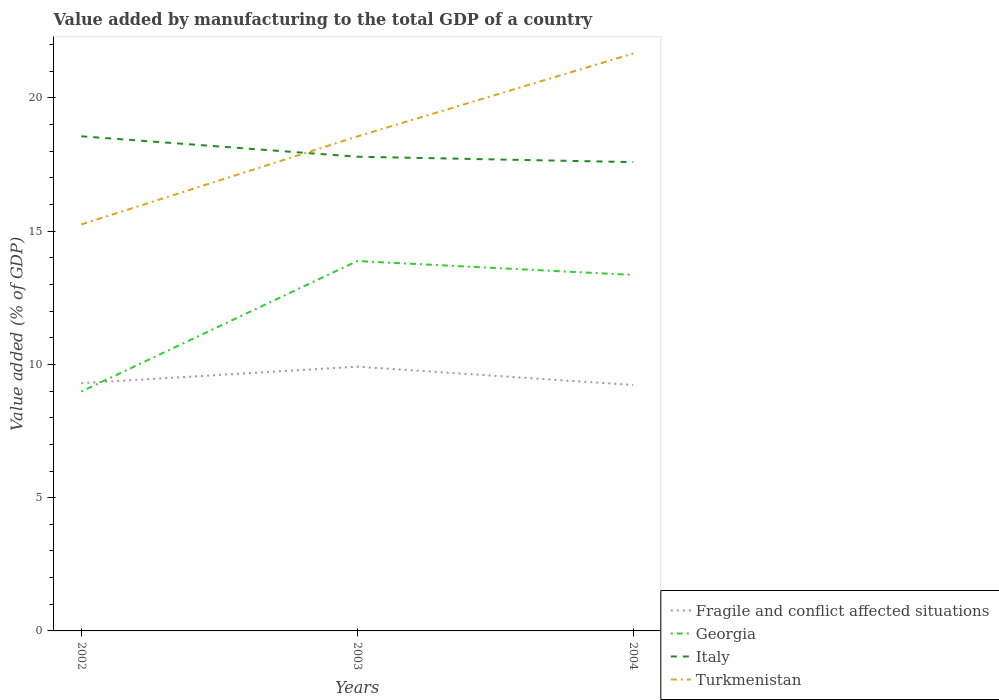Does the line corresponding to Georgia intersect with the line corresponding to Fragile and conflict affected situations?
Your response must be concise. Yes. Is the number of lines equal to the number of legend labels?
Make the answer very short. Yes. Across all years, what is the maximum value added by manufacturing to the total GDP in Georgia?
Your response must be concise. 8.98. What is the total value added by manufacturing to the total GDP in Italy in the graph?
Offer a very short reply. 0.97. What is the difference between the highest and the second highest value added by manufacturing to the total GDP in Fragile and conflict affected situations?
Ensure brevity in your answer.  0.69. Is the value added by manufacturing to the total GDP in Turkmenistan strictly greater than the value added by manufacturing to the total GDP in Italy over the years?
Your answer should be very brief. No. How many lines are there?
Ensure brevity in your answer.  4. What is the difference between two consecutive major ticks on the Y-axis?
Offer a very short reply. 5. Does the graph contain any zero values?
Provide a succinct answer. No. Where does the legend appear in the graph?
Your answer should be very brief. Bottom right. How many legend labels are there?
Offer a terse response. 4. How are the legend labels stacked?
Your answer should be very brief. Vertical. What is the title of the graph?
Give a very brief answer. Value added by manufacturing to the total GDP of a country. Does "Ethiopia" appear as one of the legend labels in the graph?
Your answer should be compact. No. What is the label or title of the Y-axis?
Your response must be concise. Value added (% of GDP). What is the Value added (% of GDP) in Fragile and conflict affected situations in 2002?
Your answer should be compact. 9.3. What is the Value added (% of GDP) in Georgia in 2002?
Provide a succinct answer. 8.98. What is the Value added (% of GDP) in Italy in 2002?
Your response must be concise. 18.56. What is the Value added (% of GDP) in Turkmenistan in 2002?
Provide a succinct answer. 15.25. What is the Value added (% of GDP) of Fragile and conflict affected situations in 2003?
Offer a very short reply. 9.92. What is the Value added (% of GDP) in Georgia in 2003?
Your response must be concise. 13.88. What is the Value added (% of GDP) in Italy in 2003?
Ensure brevity in your answer.  17.79. What is the Value added (% of GDP) of Turkmenistan in 2003?
Give a very brief answer. 18.55. What is the Value added (% of GDP) in Fragile and conflict affected situations in 2004?
Offer a terse response. 9.23. What is the Value added (% of GDP) of Georgia in 2004?
Ensure brevity in your answer.  13.36. What is the Value added (% of GDP) of Italy in 2004?
Keep it short and to the point. 17.59. What is the Value added (% of GDP) in Turkmenistan in 2004?
Your response must be concise. 21.67. Across all years, what is the maximum Value added (% of GDP) of Fragile and conflict affected situations?
Make the answer very short. 9.92. Across all years, what is the maximum Value added (% of GDP) in Georgia?
Provide a short and direct response. 13.88. Across all years, what is the maximum Value added (% of GDP) of Italy?
Offer a terse response. 18.56. Across all years, what is the maximum Value added (% of GDP) in Turkmenistan?
Offer a very short reply. 21.67. Across all years, what is the minimum Value added (% of GDP) in Fragile and conflict affected situations?
Offer a very short reply. 9.23. Across all years, what is the minimum Value added (% of GDP) in Georgia?
Offer a terse response. 8.98. Across all years, what is the minimum Value added (% of GDP) in Italy?
Your answer should be compact. 17.59. Across all years, what is the minimum Value added (% of GDP) in Turkmenistan?
Offer a terse response. 15.25. What is the total Value added (% of GDP) of Fragile and conflict affected situations in the graph?
Make the answer very short. 28.44. What is the total Value added (% of GDP) in Georgia in the graph?
Provide a short and direct response. 36.22. What is the total Value added (% of GDP) in Italy in the graph?
Give a very brief answer. 53.94. What is the total Value added (% of GDP) of Turkmenistan in the graph?
Your answer should be compact. 55.47. What is the difference between the Value added (% of GDP) of Fragile and conflict affected situations in 2002 and that in 2003?
Make the answer very short. -0.62. What is the difference between the Value added (% of GDP) in Georgia in 2002 and that in 2003?
Ensure brevity in your answer.  -4.9. What is the difference between the Value added (% of GDP) in Italy in 2002 and that in 2003?
Your response must be concise. 0.77. What is the difference between the Value added (% of GDP) of Turkmenistan in 2002 and that in 2003?
Give a very brief answer. -3.3. What is the difference between the Value added (% of GDP) in Fragile and conflict affected situations in 2002 and that in 2004?
Your answer should be very brief. 0.07. What is the difference between the Value added (% of GDP) in Georgia in 2002 and that in 2004?
Your answer should be compact. -4.38. What is the difference between the Value added (% of GDP) of Italy in 2002 and that in 2004?
Provide a short and direct response. 0.97. What is the difference between the Value added (% of GDP) of Turkmenistan in 2002 and that in 2004?
Offer a terse response. -6.42. What is the difference between the Value added (% of GDP) of Fragile and conflict affected situations in 2003 and that in 2004?
Your answer should be compact. 0.69. What is the difference between the Value added (% of GDP) of Georgia in 2003 and that in 2004?
Your answer should be very brief. 0.52. What is the difference between the Value added (% of GDP) of Italy in 2003 and that in 2004?
Your response must be concise. 0.2. What is the difference between the Value added (% of GDP) in Turkmenistan in 2003 and that in 2004?
Keep it short and to the point. -3.11. What is the difference between the Value added (% of GDP) of Fragile and conflict affected situations in 2002 and the Value added (% of GDP) of Georgia in 2003?
Provide a succinct answer. -4.58. What is the difference between the Value added (% of GDP) of Fragile and conflict affected situations in 2002 and the Value added (% of GDP) of Italy in 2003?
Keep it short and to the point. -8.5. What is the difference between the Value added (% of GDP) in Fragile and conflict affected situations in 2002 and the Value added (% of GDP) in Turkmenistan in 2003?
Your answer should be very brief. -9.26. What is the difference between the Value added (% of GDP) of Georgia in 2002 and the Value added (% of GDP) of Italy in 2003?
Give a very brief answer. -8.81. What is the difference between the Value added (% of GDP) in Georgia in 2002 and the Value added (% of GDP) in Turkmenistan in 2003?
Make the answer very short. -9.57. What is the difference between the Value added (% of GDP) in Italy in 2002 and the Value added (% of GDP) in Turkmenistan in 2003?
Keep it short and to the point. 0.01. What is the difference between the Value added (% of GDP) of Fragile and conflict affected situations in 2002 and the Value added (% of GDP) of Georgia in 2004?
Provide a short and direct response. -4.06. What is the difference between the Value added (% of GDP) in Fragile and conflict affected situations in 2002 and the Value added (% of GDP) in Italy in 2004?
Offer a terse response. -8.29. What is the difference between the Value added (% of GDP) of Fragile and conflict affected situations in 2002 and the Value added (% of GDP) of Turkmenistan in 2004?
Your answer should be compact. -12.37. What is the difference between the Value added (% of GDP) of Georgia in 2002 and the Value added (% of GDP) of Italy in 2004?
Provide a short and direct response. -8.61. What is the difference between the Value added (% of GDP) in Georgia in 2002 and the Value added (% of GDP) in Turkmenistan in 2004?
Provide a succinct answer. -12.68. What is the difference between the Value added (% of GDP) in Italy in 2002 and the Value added (% of GDP) in Turkmenistan in 2004?
Give a very brief answer. -3.11. What is the difference between the Value added (% of GDP) in Fragile and conflict affected situations in 2003 and the Value added (% of GDP) in Georgia in 2004?
Offer a terse response. -3.44. What is the difference between the Value added (% of GDP) of Fragile and conflict affected situations in 2003 and the Value added (% of GDP) of Italy in 2004?
Keep it short and to the point. -7.67. What is the difference between the Value added (% of GDP) in Fragile and conflict affected situations in 2003 and the Value added (% of GDP) in Turkmenistan in 2004?
Offer a terse response. -11.75. What is the difference between the Value added (% of GDP) of Georgia in 2003 and the Value added (% of GDP) of Italy in 2004?
Provide a succinct answer. -3.71. What is the difference between the Value added (% of GDP) of Georgia in 2003 and the Value added (% of GDP) of Turkmenistan in 2004?
Keep it short and to the point. -7.79. What is the difference between the Value added (% of GDP) in Italy in 2003 and the Value added (% of GDP) in Turkmenistan in 2004?
Keep it short and to the point. -3.87. What is the average Value added (% of GDP) of Fragile and conflict affected situations per year?
Offer a very short reply. 9.48. What is the average Value added (% of GDP) in Georgia per year?
Your answer should be compact. 12.07. What is the average Value added (% of GDP) of Italy per year?
Ensure brevity in your answer.  17.98. What is the average Value added (% of GDP) of Turkmenistan per year?
Keep it short and to the point. 18.49. In the year 2002, what is the difference between the Value added (% of GDP) in Fragile and conflict affected situations and Value added (% of GDP) in Georgia?
Ensure brevity in your answer.  0.31. In the year 2002, what is the difference between the Value added (% of GDP) of Fragile and conflict affected situations and Value added (% of GDP) of Italy?
Offer a terse response. -9.26. In the year 2002, what is the difference between the Value added (% of GDP) of Fragile and conflict affected situations and Value added (% of GDP) of Turkmenistan?
Provide a short and direct response. -5.96. In the year 2002, what is the difference between the Value added (% of GDP) in Georgia and Value added (% of GDP) in Italy?
Make the answer very short. -9.58. In the year 2002, what is the difference between the Value added (% of GDP) of Georgia and Value added (% of GDP) of Turkmenistan?
Your response must be concise. -6.27. In the year 2002, what is the difference between the Value added (% of GDP) in Italy and Value added (% of GDP) in Turkmenistan?
Your answer should be very brief. 3.31. In the year 2003, what is the difference between the Value added (% of GDP) of Fragile and conflict affected situations and Value added (% of GDP) of Georgia?
Your answer should be very brief. -3.96. In the year 2003, what is the difference between the Value added (% of GDP) of Fragile and conflict affected situations and Value added (% of GDP) of Italy?
Keep it short and to the point. -7.88. In the year 2003, what is the difference between the Value added (% of GDP) of Fragile and conflict affected situations and Value added (% of GDP) of Turkmenistan?
Make the answer very short. -8.64. In the year 2003, what is the difference between the Value added (% of GDP) in Georgia and Value added (% of GDP) in Italy?
Your answer should be very brief. -3.91. In the year 2003, what is the difference between the Value added (% of GDP) of Georgia and Value added (% of GDP) of Turkmenistan?
Ensure brevity in your answer.  -4.67. In the year 2003, what is the difference between the Value added (% of GDP) in Italy and Value added (% of GDP) in Turkmenistan?
Make the answer very short. -0.76. In the year 2004, what is the difference between the Value added (% of GDP) in Fragile and conflict affected situations and Value added (% of GDP) in Georgia?
Your answer should be compact. -4.13. In the year 2004, what is the difference between the Value added (% of GDP) in Fragile and conflict affected situations and Value added (% of GDP) in Italy?
Your answer should be compact. -8.36. In the year 2004, what is the difference between the Value added (% of GDP) in Fragile and conflict affected situations and Value added (% of GDP) in Turkmenistan?
Offer a very short reply. -12.44. In the year 2004, what is the difference between the Value added (% of GDP) of Georgia and Value added (% of GDP) of Italy?
Provide a succinct answer. -4.23. In the year 2004, what is the difference between the Value added (% of GDP) of Georgia and Value added (% of GDP) of Turkmenistan?
Offer a very short reply. -8.31. In the year 2004, what is the difference between the Value added (% of GDP) of Italy and Value added (% of GDP) of Turkmenistan?
Keep it short and to the point. -4.08. What is the ratio of the Value added (% of GDP) of Fragile and conflict affected situations in 2002 to that in 2003?
Offer a terse response. 0.94. What is the ratio of the Value added (% of GDP) of Georgia in 2002 to that in 2003?
Ensure brevity in your answer.  0.65. What is the ratio of the Value added (% of GDP) of Italy in 2002 to that in 2003?
Your answer should be compact. 1.04. What is the ratio of the Value added (% of GDP) of Turkmenistan in 2002 to that in 2003?
Offer a very short reply. 0.82. What is the ratio of the Value added (% of GDP) of Fragile and conflict affected situations in 2002 to that in 2004?
Offer a terse response. 1.01. What is the ratio of the Value added (% of GDP) in Georgia in 2002 to that in 2004?
Provide a short and direct response. 0.67. What is the ratio of the Value added (% of GDP) of Italy in 2002 to that in 2004?
Provide a succinct answer. 1.06. What is the ratio of the Value added (% of GDP) in Turkmenistan in 2002 to that in 2004?
Ensure brevity in your answer.  0.7. What is the ratio of the Value added (% of GDP) of Fragile and conflict affected situations in 2003 to that in 2004?
Make the answer very short. 1.07. What is the ratio of the Value added (% of GDP) in Georgia in 2003 to that in 2004?
Give a very brief answer. 1.04. What is the ratio of the Value added (% of GDP) in Italy in 2003 to that in 2004?
Give a very brief answer. 1.01. What is the ratio of the Value added (% of GDP) of Turkmenistan in 2003 to that in 2004?
Your response must be concise. 0.86. What is the difference between the highest and the second highest Value added (% of GDP) in Fragile and conflict affected situations?
Provide a succinct answer. 0.62. What is the difference between the highest and the second highest Value added (% of GDP) of Georgia?
Make the answer very short. 0.52. What is the difference between the highest and the second highest Value added (% of GDP) of Italy?
Ensure brevity in your answer.  0.77. What is the difference between the highest and the second highest Value added (% of GDP) in Turkmenistan?
Your answer should be compact. 3.11. What is the difference between the highest and the lowest Value added (% of GDP) of Fragile and conflict affected situations?
Offer a terse response. 0.69. What is the difference between the highest and the lowest Value added (% of GDP) in Georgia?
Your answer should be compact. 4.9. What is the difference between the highest and the lowest Value added (% of GDP) in Italy?
Your answer should be compact. 0.97. What is the difference between the highest and the lowest Value added (% of GDP) in Turkmenistan?
Give a very brief answer. 6.42. 